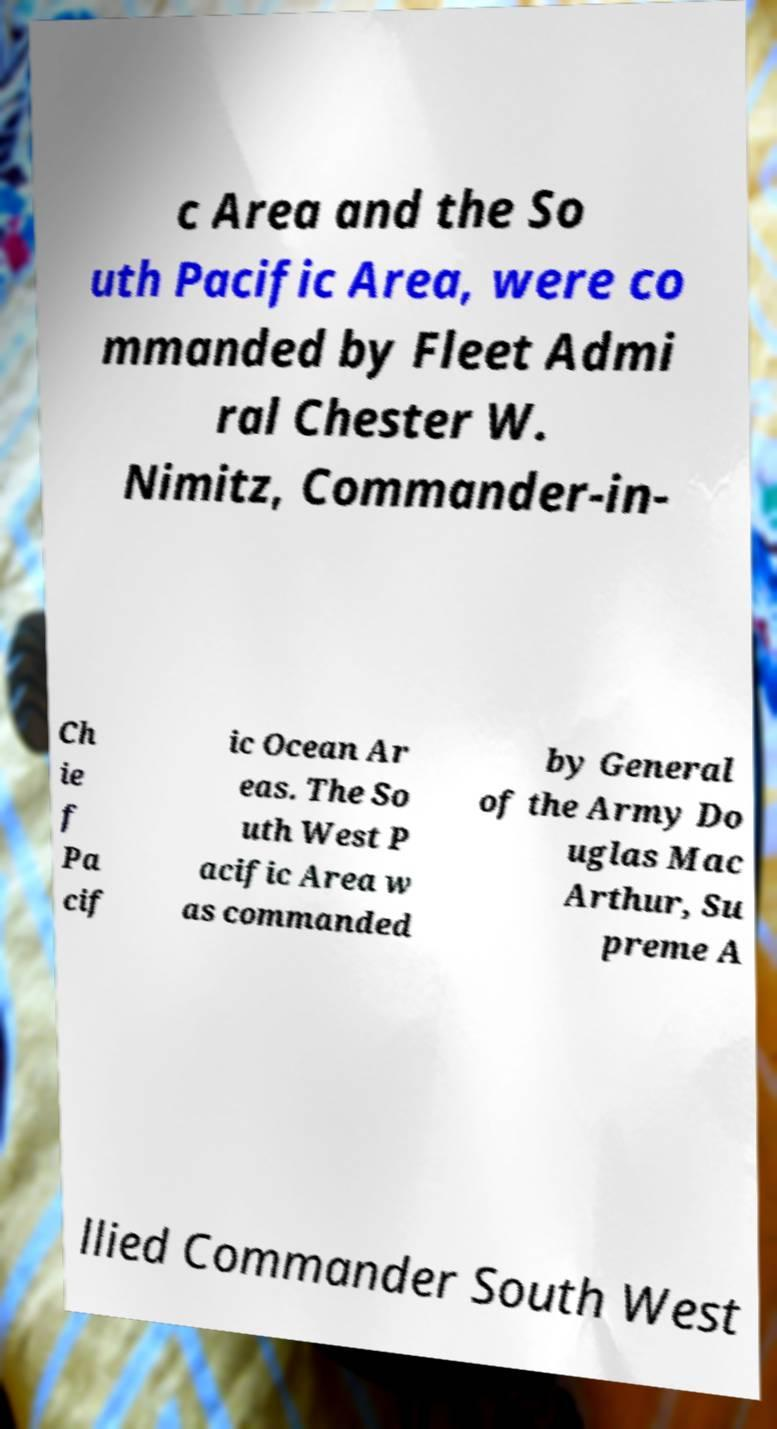I need the written content from this picture converted into text. Can you do that? c Area and the So uth Pacific Area, were co mmanded by Fleet Admi ral Chester W. Nimitz, Commander-in- Ch ie f Pa cif ic Ocean Ar eas. The So uth West P acific Area w as commanded by General of the Army Do uglas Mac Arthur, Su preme A llied Commander South West 